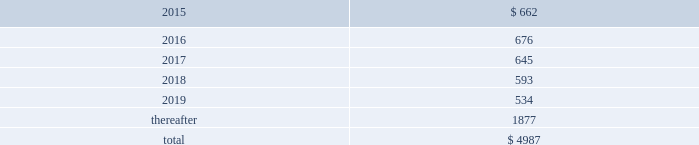Table of contents concentrations in the available sources of supply of materials and product although most components essential to the company 2019s business are generally available from multiple sources , a number of components are currently obtained from single or limited sources .
In addition , the company competes for various components with other participants in the markets for mobile communication and media devices and personal computers .
Therefore , many components used by the company , including those that are available from multiple sources , are at times subject to industry-wide shortage and significant pricing fluctuations that could materially adversely affect the company 2019s financial condition and operating results .
The company uses some custom components that are not commonly used by its competitors , and new products introduced by the company often utilize custom components available from only one source .
When a component or product uses new technologies , initial capacity constraints may exist until the suppliers 2019 yields have matured or manufacturing capacity has increased .
If the company 2019s supply of components for a new or existing product were delayed or constrained , or if an outsourcing partner delayed shipments of completed products to the company , the company 2019s financial condition and operating results could be materially adversely affected .
The company 2019s business and financial performance could also be materially adversely affected depending on the time required to obtain sufficient quantities from the original source , or to identify and obtain sufficient quantities from an alternative source .
Continued availability of these components at acceptable prices , or at all , may be affected if those suppliers concentrated on the production of common components instead of components customized to meet the company 2019s requirements .
The company has entered into agreements for the supply of many components ; however , there can be no guarantee that the company will be able to extend or renew these agreements on similar terms , or at all .
Therefore , the company remains subject to significant risks of supply shortages and price increases that could materially adversely affect its financial condition and operating results .
Substantially all of the company 2019s hardware products are manufactured by outsourcing partners that are located primarily in asia .
A significant concentration of this manufacturing is currently performed by a small number of outsourcing partners , often in single locations .
Certain of these outsourcing partners are the sole-sourced suppliers of components and manufacturers for many of the company 2019s products .
Although the company works closely with its outsourcing partners on manufacturing schedules , the company 2019s operating results could be adversely affected if its outsourcing partners were unable to meet their production commitments .
The company 2019s purchase commitments typically cover its requirements for periods up to 150 days .
Other off-balance sheet commitments operating leases the company leases various equipment and facilities , including retail space , under noncancelable operating lease arrangements .
The company does not currently utilize any other off-balance sheet financing arrangements .
The major facility leases are typically for terms not exceeding 10 years and generally contain multi-year renewal options .
Leases for retail space are for terms ranging from five to 20 years , the majority of which are for 10 years , and often contain multi-year renewal options .
As of september 27 , 2014 , the company 2019s total future minimum lease payments under noncancelable operating leases were $ 5.0 billion , of which $ 3.6 billion related to leases for retail space .
Rent expense under all operating leases , including both cancelable and noncancelable leases , was $ 717 million , $ 645 million and $ 488 million in 2014 , 2013 and 2012 , respectively .
Future minimum lease payments under noncancelable operating leases having remaining terms in excess of one year as of september 27 , 2014 , are as follows ( in millions ) : apple inc .
| 2014 form 10-k | 75 .

What percentage of future minimum lease payments under noncancelable operating leases are due in 2017? 
Computations: (645 / 4987)
Answer: 0.12934. 